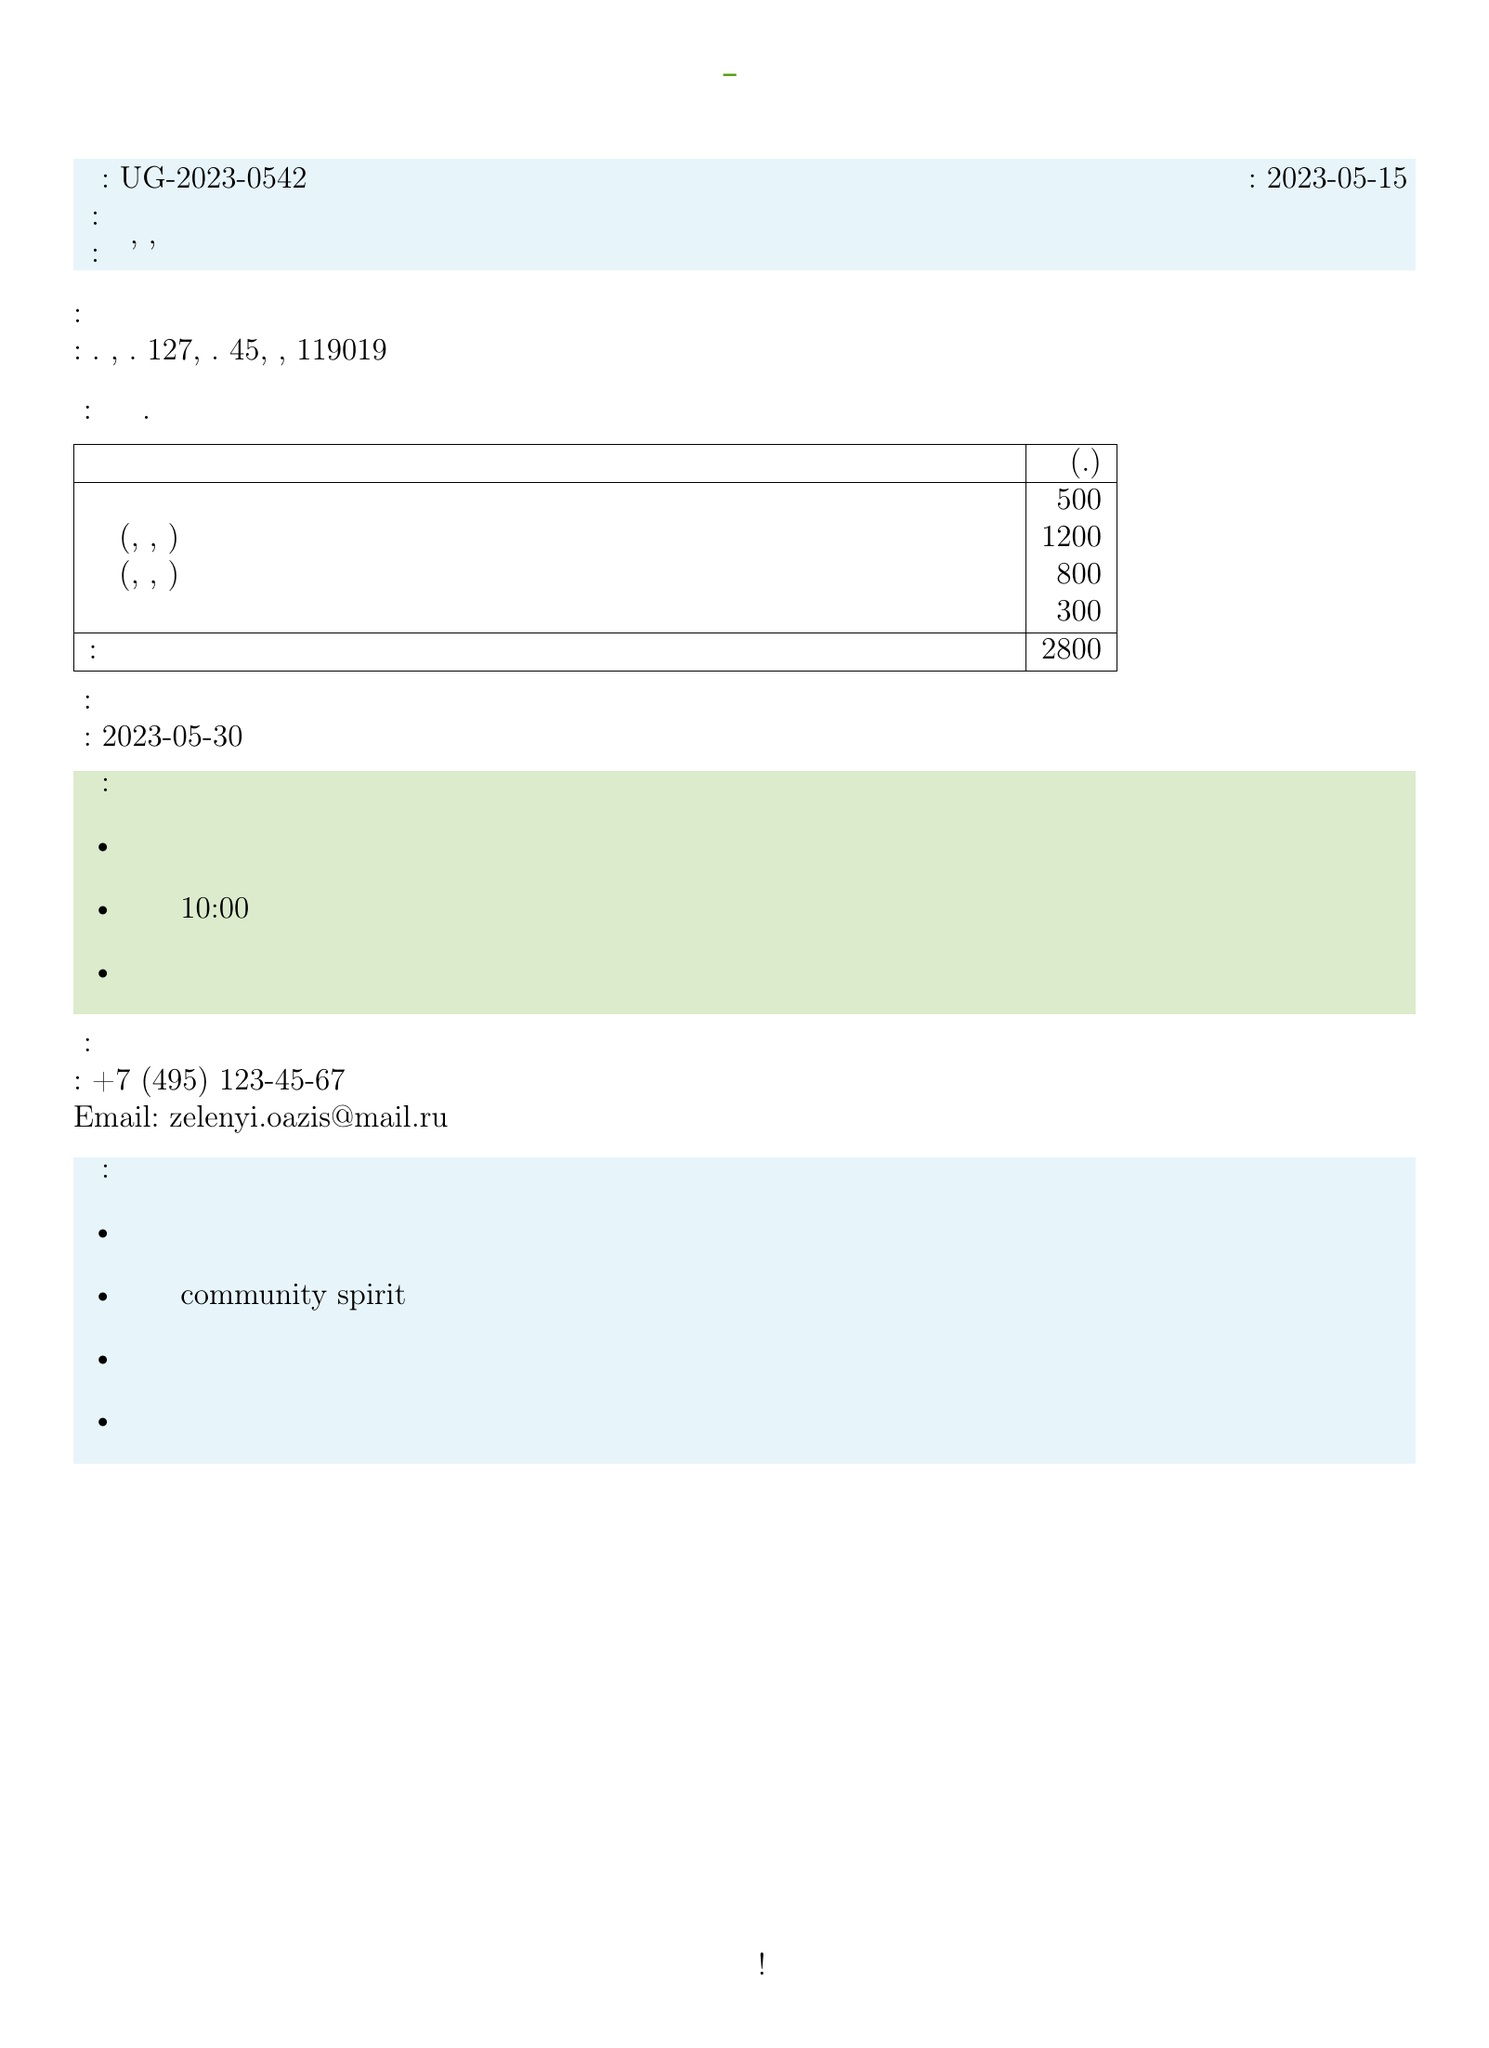What is the invoice number? The invoice number is a unique identifier for the transaction provided in the document.
Answer: UG-2023-0542 When is the payment due? The payment due date is specified in the document, indicating when the payment should be made.
Answer: 2023-05-30 What is the total amount for the invoice? The total amount combines all the charges listed in the document.
Answer: 2800 Who is the contact person for the project? The contact person's name is provided for any inquiries regarding the project or invoice.
Answer: Мария Ивановна Кузнецова What is the project description about? The project description provides insights into the goal of the initiative as stated in the document.
Answer: Преобразование заброшенного участка на ул. Пушкина в общественный сад What benefits do participants get from joining the project? The document outlines personal benefits showing what participants can gain through involvement.
Answer: Возможность выращивать собственные экологически чистые продукты How is the payment supposed to be made? This specifies the methods of payment accepted for the invoice in the document.
Answer: Наличными или переводом на карту Сбербанка What type of project is "Зеленый Оазис Коммуны"? This question assesses what kind of initiative the document describes.
Answer: Сообщественное садоводство What is one of the success stories mentioned? This seeks an example of previously successful projects to emphasize credibility.
Answer: Похожий проект в Санкт-Петербурге привел к созданию популярного общественного пространства 